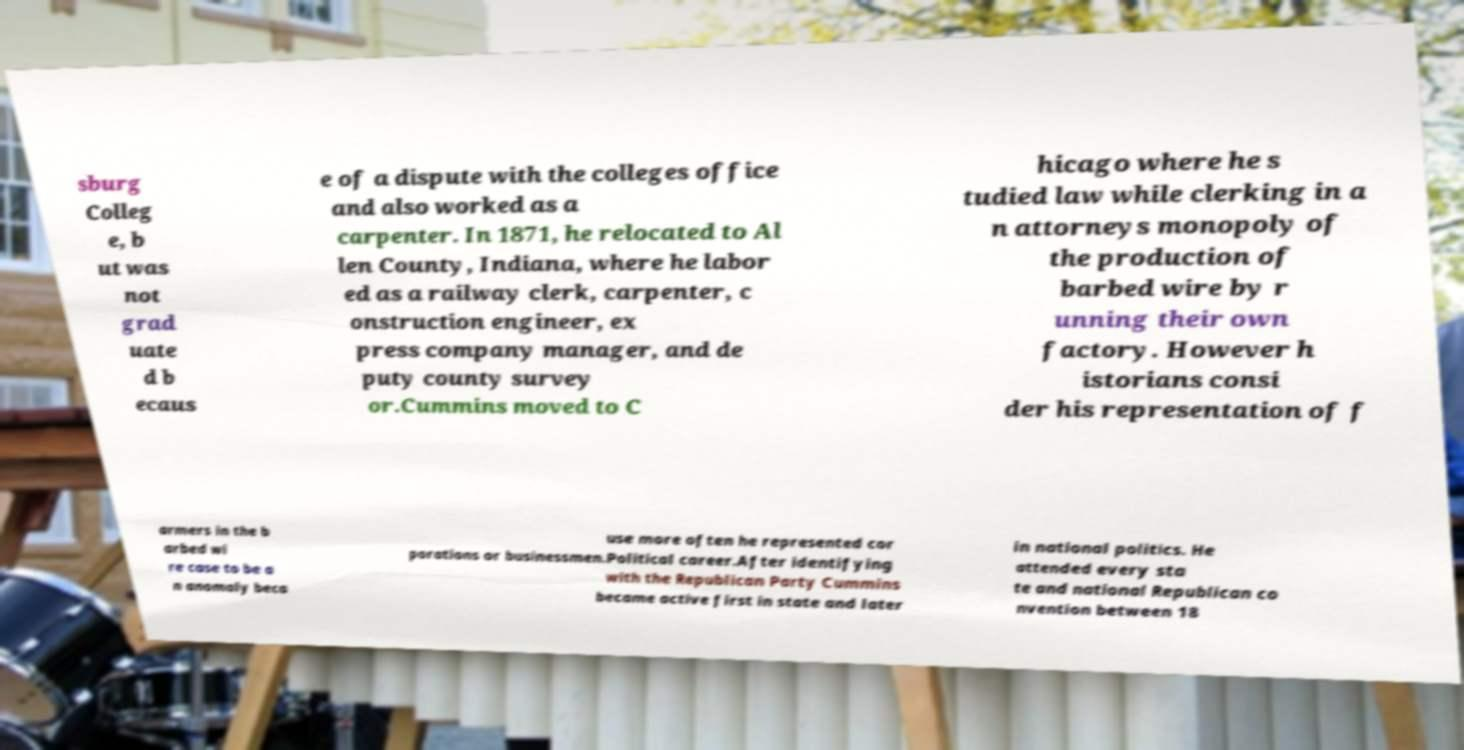Can you accurately transcribe the text from the provided image for me? sburg Colleg e, b ut was not grad uate d b ecaus e of a dispute with the colleges office and also worked as a carpenter. In 1871, he relocated to Al len County, Indiana, where he labor ed as a railway clerk, carpenter, c onstruction engineer, ex press company manager, and de puty county survey or.Cummins moved to C hicago where he s tudied law while clerking in a n attorneys monopoly of the production of barbed wire by r unning their own factory. However h istorians consi der his representation of f armers in the b arbed wi re case to be a n anomaly beca use more often he represented cor porations or businessmen.Political career.After identifying with the Republican Party Cummins became active first in state and later in national politics. He attended every sta te and national Republican co nvention between 18 